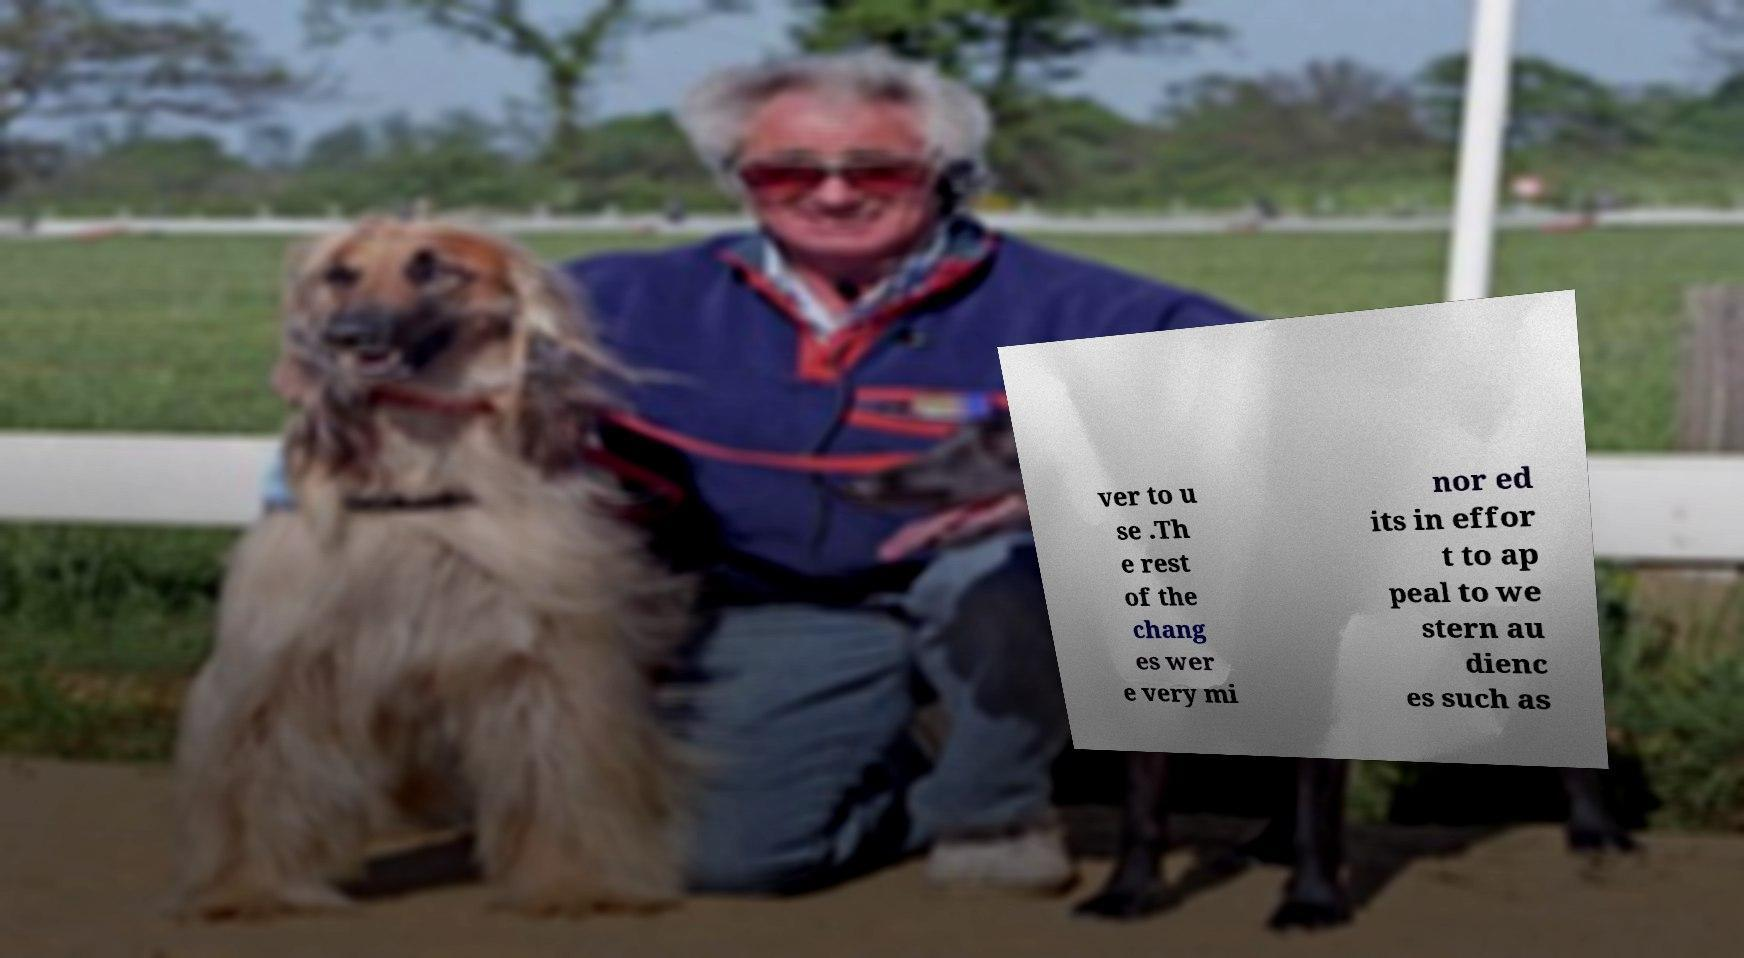Can you read and provide the text displayed in the image?This photo seems to have some interesting text. Can you extract and type it out for me? ver to u se .Th e rest of the chang es wer e very mi nor ed its in effor t to ap peal to we stern au dienc es such as 